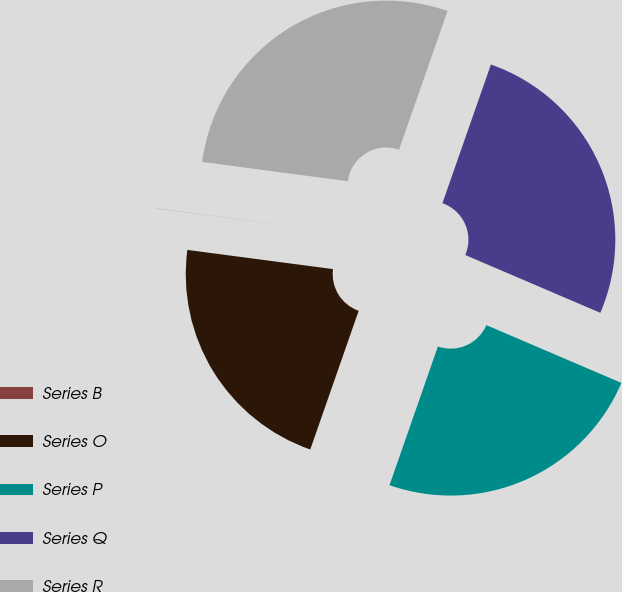Convert chart to OTSL. <chart><loc_0><loc_0><loc_500><loc_500><pie_chart><fcel>Series B<fcel>Series O<fcel>Series P<fcel>Series Q<fcel>Series R<nl><fcel>0.01%<fcel>21.74%<fcel>23.91%<fcel>26.08%<fcel>28.26%<nl></chart> 